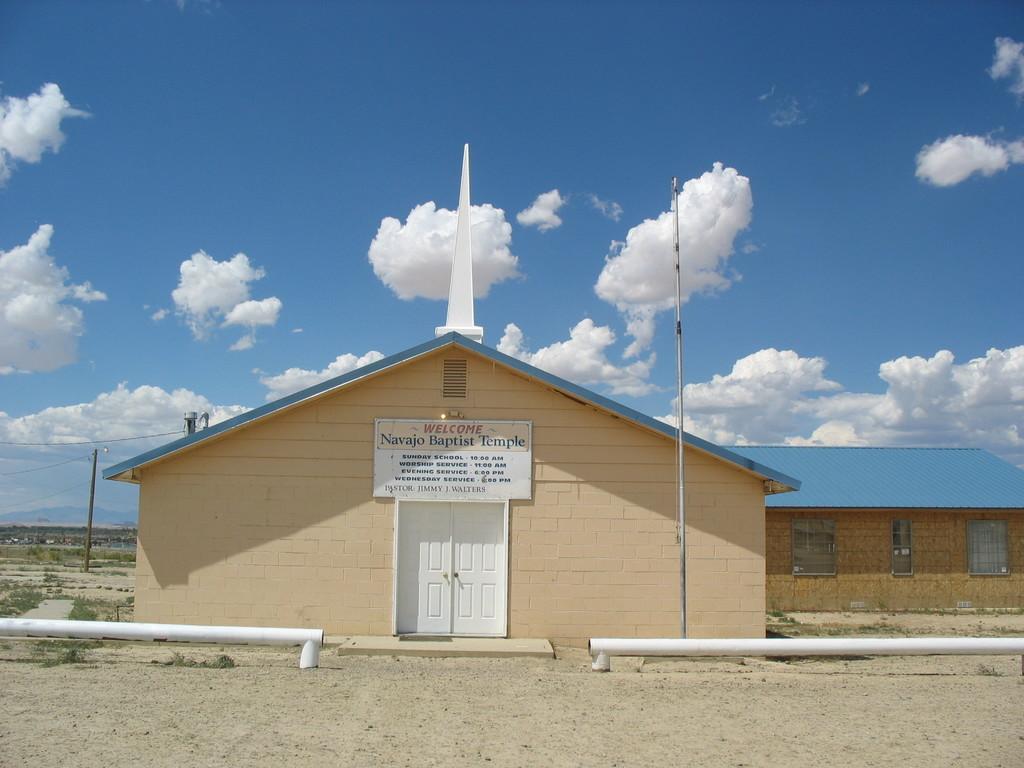Please provide a concise description of this image. In this picture we can see a house with windows, doors, name board, poles, grass and in the background we can see the sky with clouds. 